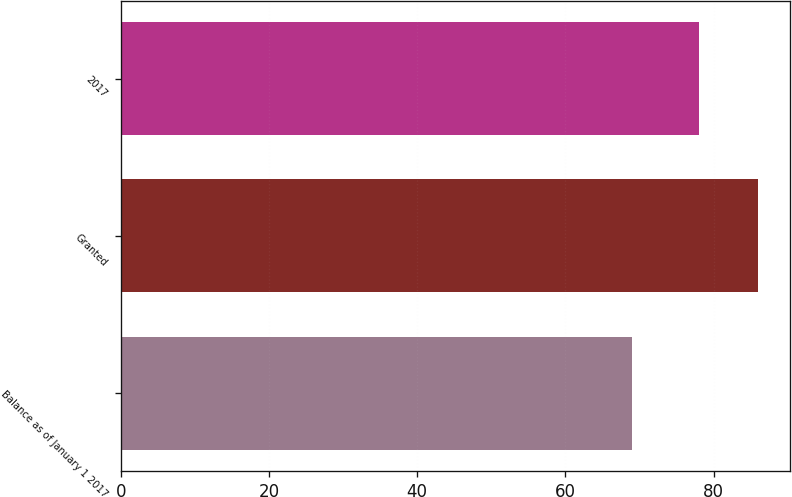Convert chart to OTSL. <chart><loc_0><loc_0><loc_500><loc_500><bar_chart><fcel>Balance as of January 1 2017<fcel>Granted<fcel>2017<nl><fcel>69<fcel>86<fcel>78<nl></chart> 